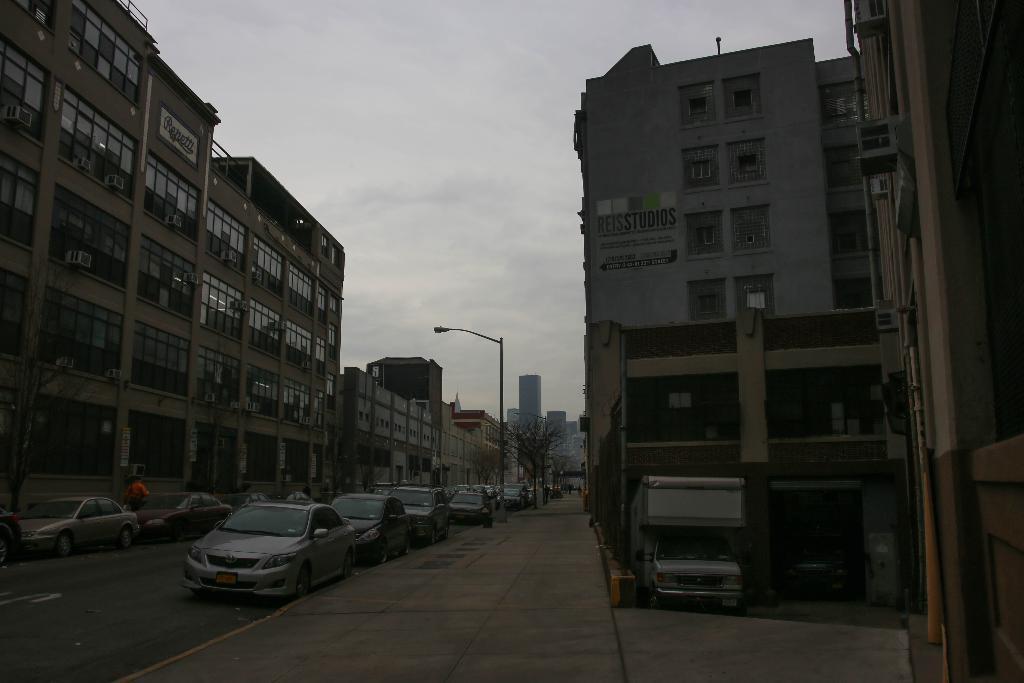Could you give a brief overview of what you see in this image? This picture is clicked outside. On the left we can see the group of cars and we can see the buildings. In the center there is a street light attached to the pole. In the background there is a sky, tree and the buildings and some other objects. On the right we can see the text on the building. 